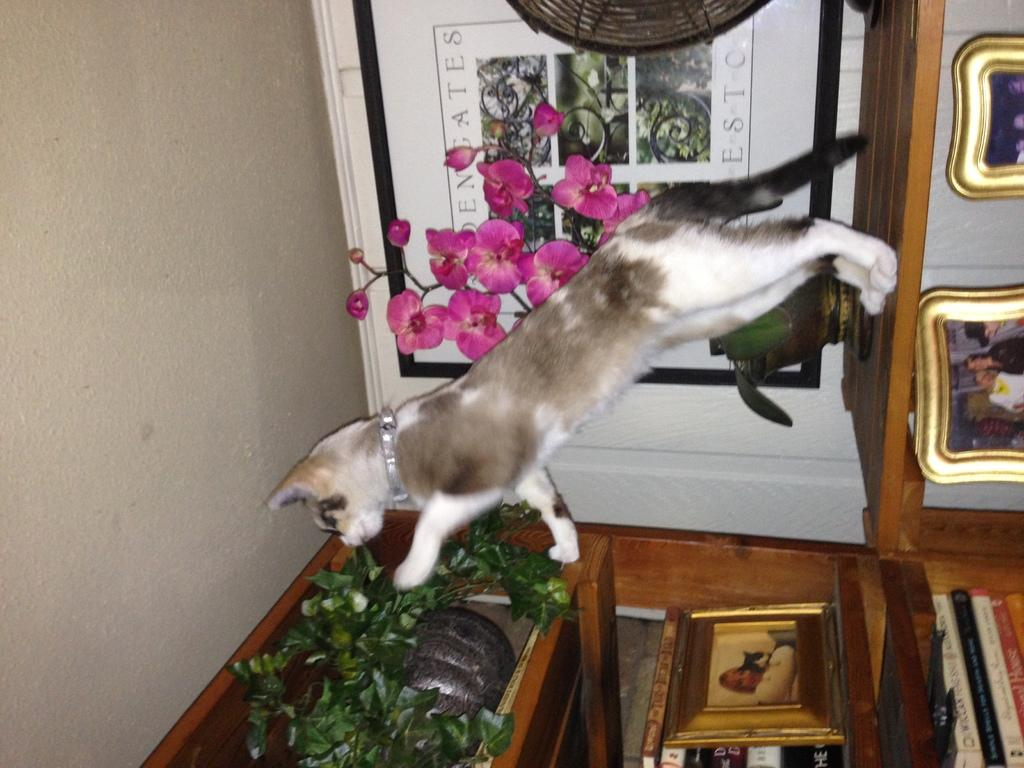What type of animal can be seen in the picture? There is a cat in the picture. What is hanging on the wall in the picture? There are frames on the wall. What type of furniture is present in the picture? There are bookshelves in the picture. What is inside the wooden box in the picture? There are leaves in the wooden box. Can you tell me how many people are playing chess in the picture? There is no chess game or crowd present in the picture; it features a cat, frames on the wall, bookshelves, and a wooden box with leaves. 